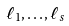Convert formula to latex. <formula><loc_0><loc_0><loc_500><loc_500>\ell _ { 1 } , \dots , \ell _ { s }</formula> 